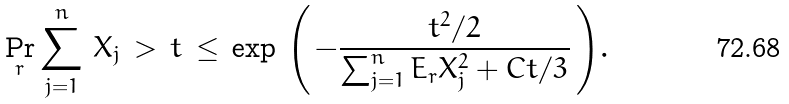Convert formula to latex. <formula><loc_0><loc_0><loc_500><loc_500>\Pr _ { r } { \sum _ { j = 1 } ^ { n } \, X _ { j } \, > \, t } \, \leq \, \exp { \, \left ( \, - \frac { t ^ { 2 } / 2 } { \sum _ { j = 1 } ^ { n } E _ { r } { X _ { j } ^ { 2 } } + C t / 3 } \, \right ) } .</formula> 